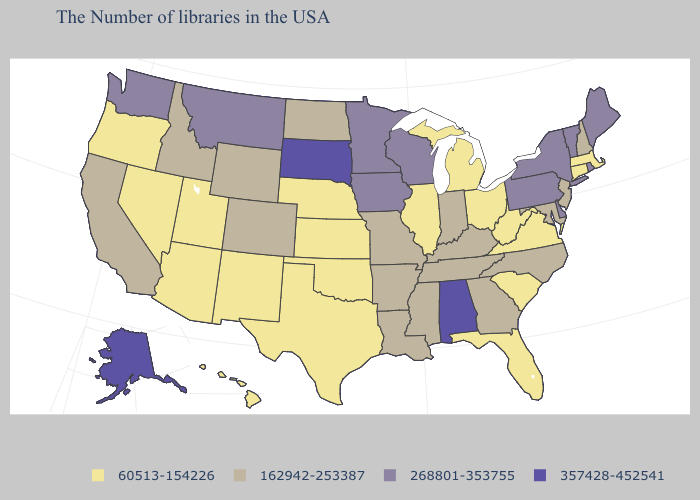Does the first symbol in the legend represent the smallest category?
Quick response, please. Yes. Among the states that border Arkansas , which have the highest value?
Concise answer only. Tennessee, Mississippi, Louisiana, Missouri. Name the states that have a value in the range 60513-154226?
Concise answer only. Massachusetts, Connecticut, Virginia, South Carolina, West Virginia, Ohio, Florida, Michigan, Illinois, Kansas, Nebraska, Oklahoma, Texas, New Mexico, Utah, Arizona, Nevada, Oregon, Hawaii. Name the states that have a value in the range 357428-452541?
Write a very short answer. Alabama, South Dakota, Alaska. Does the first symbol in the legend represent the smallest category?
Concise answer only. Yes. What is the value of New York?
Write a very short answer. 268801-353755. Among the states that border Utah , which have the lowest value?
Give a very brief answer. New Mexico, Arizona, Nevada. Does Washington have a higher value than Nevada?
Answer briefly. Yes. Which states have the lowest value in the Northeast?
Give a very brief answer. Massachusetts, Connecticut. Does Virginia have the lowest value in the USA?
Give a very brief answer. Yes. Does Illinois have a lower value than Maryland?
Write a very short answer. Yes. Does Montana have the same value as Oklahoma?
Be succinct. No. Among the states that border Nevada , which have the lowest value?
Keep it brief. Utah, Arizona, Oregon. Does Rhode Island have the highest value in the Northeast?
Quick response, please. Yes. 